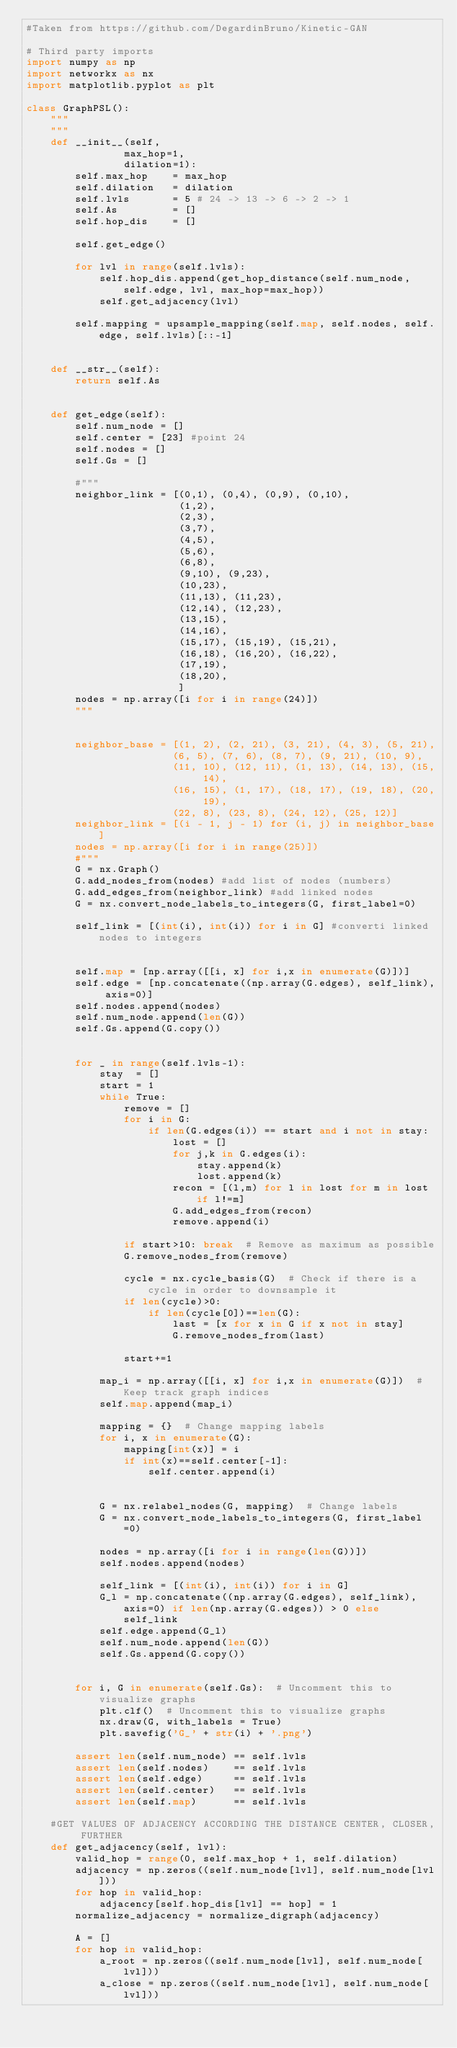<code> <loc_0><loc_0><loc_500><loc_500><_Python_>#Taken from https://github.com/DegardinBruno/Kinetic-GAN

# Third party imports
import numpy as np
import networkx as nx
import matplotlib.pyplot as plt

class GraphPSL():
    """
    """
    def __init__(self,
                max_hop=1,
                dilation=1):
        self.max_hop    = max_hop
        self.dilation   = dilation
        self.lvls       = 5 # 24 -> 13 -> 6 -> 2 -> 1
        self.As         = []
        self.hop_dis    = []

        self.get_edge()

        for lvl in range(self.lvls):
            self.hop_dis.append(get_hop_distance(self.num_node, self.edge, lvl, max_hop=max_hop))
            self.get_adjacency(lvl)

        self.mapping = upsample_mapping(self.map, self.nodes, self.edge, self.lvls)[::-1]

    
    def __str__(self):
        return self.As

    
    def get_edge(self):
        self.num_node = []
        self.center = [23] #point 24
        self.nodes = []
        self.Gs = []
        
        #"""
        neighbor_link = [(0,1), (0,4), (0,9), (0,10),
                         (1,2),
                         (2,3),
                         (3,7),
                         (4,5),
                         (5,6),
                         (6,8),
                         (9,10), (9,23),
                         (10,23),
                         (11,13), (11,23),
                         (12,14), (12,23),
                         (13,15),
                         (14,16),
                         (15,17), (15,19), (15,21),
                         (16,18), (16,20), (16,22),
                         (17,19),
                         (18,20),
                         ]
        nodes = np.array([i for i in range(24)])
        """
        
        
        neighbor_base = [(1, 2), (2, 21), (3, 21), (4, 3), (5, 21),
                        (6, 5), (7, 6), (8, 7), (9, 21), (10, 9),
                        (11, 10), (12, 11), (1, 13), (14, 13), (15, 14),
                        (16, 15), (1, 17), (18, 17), (19, 18), (20, 19),
                        (22, 8), (23, 8), (24, 12), (25, 12)]
        neighbor_link = [(i - 1, j - 1) for (i, j) in neighbor_base]
        nodes = np.array([i for i in range(25)])
        #"""
        G = nx.Graph()
        G.add_nodes_from(nodes) #add list of nodes (numbers)
        G.add_edges_from(neighbor_link) #add linked nodes
        G = nx.convert_node_labels_to_integers(G, first_label=0)

        self_link = [(int(i), int(i)) for i in G] #converti linked nodes to integers


        self.map = [np.array([[i, x] for i,x in enumerate(G)])]
        self.edge = [np.concatenate((np.array(G.edges), self_link), axis=0)]
        self.nodes.append(nodes)
        self.num_node.append(len(G))
        self.Gs.append(G.copy())


        for _ in range(self.lvls-1):
            stay  = []
            start = 1
            while True:
                remove = []
                for i in G:
                    if len(G.edges(i)) == start and i not in stay:
                        lost = []
                        for j,k in G.edges(i):
                            stay.append(k)
                            lost.append(k)
                        recon = [(l,m) for l in lost for m in lost if l!=m]
                        G.add_edges_from(recon)            
                        remove.append(i)

                if start>10: break  # Remove as maximum as possible
                G.remove_nodes_from(remove)

                cycle = nx.cycle_basis(G)  # Check if there is a cycle in order to downsample it
                if len(cycle)>0:
                    if len(cycle[0])==len(G):
                        last = [x for x in G if x not in stay]
                        G.remove_nodes_from(last)

                start+=1

            map_i = np.array([[i, x] for i,x in enumerate(G)])  # Keep track graph indices
            self.map.append(map_i)

            mapping = {}  # Change mapping labels
            for i, x in enumerate(G): 
                mapping[int(x)] = i
                if int(x)==self.center[-1]:
                    self.center.append(i)
            

            G = nx.relabel_nodes(G, mapping)  # Change labels
            G = nx.convert_node_labels_to_integers(G, first_label=0)
            
            nodes = np.array([i for i in range(len(G))])
            self.nodes.append(nodes)

            self_link = [(int(i), int(i)) for i in G]
            G_l = np.concatenate((np.array(G.edges), self_link), axis=0) if len(np.array(G.edges)) > 0 else self_link
            self.edge.append(G_l)
            self.num_node.append(len(G))
            self.Gs.append(G.copy())

        
        for i, G in enumerate(self.Gs):  # Uncomment this to visualize graphs
            plt.clf()  # Uncomment this to visualize graphs
            nx.draw(G, with_labels = True)
            plt.savefig('G_' + str(i) + '.png')

        assert len(self.num_node) == self.lvls
        assert len(self.nodes)    == self.lvls
        assert len(self.edge)     == self.lvls
        assert len(self.center)   == self.lvls
        assert len(self.map)      == self.lvls

    #GET VALUES OF ADJACENCY ACCORDING THE DISTANCE CENTER, CLOSER, FURTHER
    def get_adjacency(self, lvl):
        valid_hop = range(0, self.max_hop + 1, self.dilation)
        adjacency = np.zeros((self.num_node[lvl], self.num_node[lvl]))
        for hop in valid_hop:
            adjacency[self.hop_dis[lvl] == hop] = 1
        normalize_adjacency = normalize_digraph(adjacency)

        A = []
        for hop in valid_hop:
            a_root = np.zeros((self.num_node[lvl], self.num_node[lvl]))
            a_close = np.zeros((self.num_node[lvl], self.num_node[lvl]))</code> 